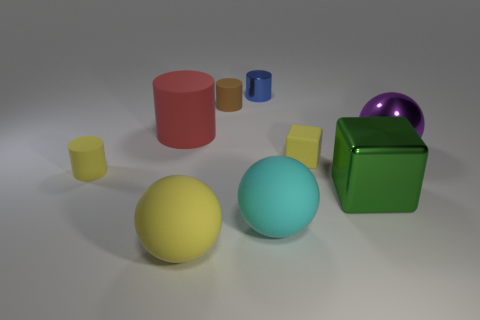Is there any other thing that has the same color as the rubber block?
Keep it short and to the point. Yes. Are there the same number of big green metal cubes that are in front of the large yellow rubber object and objects that are left of the large purple object?
Your answer should be very brief. No. Is the number of brown matte cylinders that are behind the big yellow rubber object greater than the number of red cubes?
Your response must be concise. Yes. What number of things are yellow matte things that are in front of the small yellow cylinder or yellow cylinders?
Your answer should be compact. 2. How many small yellow cubes have the same material as the tiny yellow cylinder?
Offer a terse response. 1. There is a tiny object that is the same color as the small cube; what is its shape?
Your answer should be very brief. Cylinder. Are there any blue things of the same shape as the purple thing?
Offer a terse response. No. What shape is the cyan object that is the same size as the green block?
Keep it short and to the point. Sphere. There is a metallic ball; does it have the same color as the big matte thing that is behind the cyan ball?
Make the answer very short. No. What number of large cyan objects are to the left of the tiny matte cylinder that is behind the large purple shiny sphere?
Your answer should be compact. 0. 